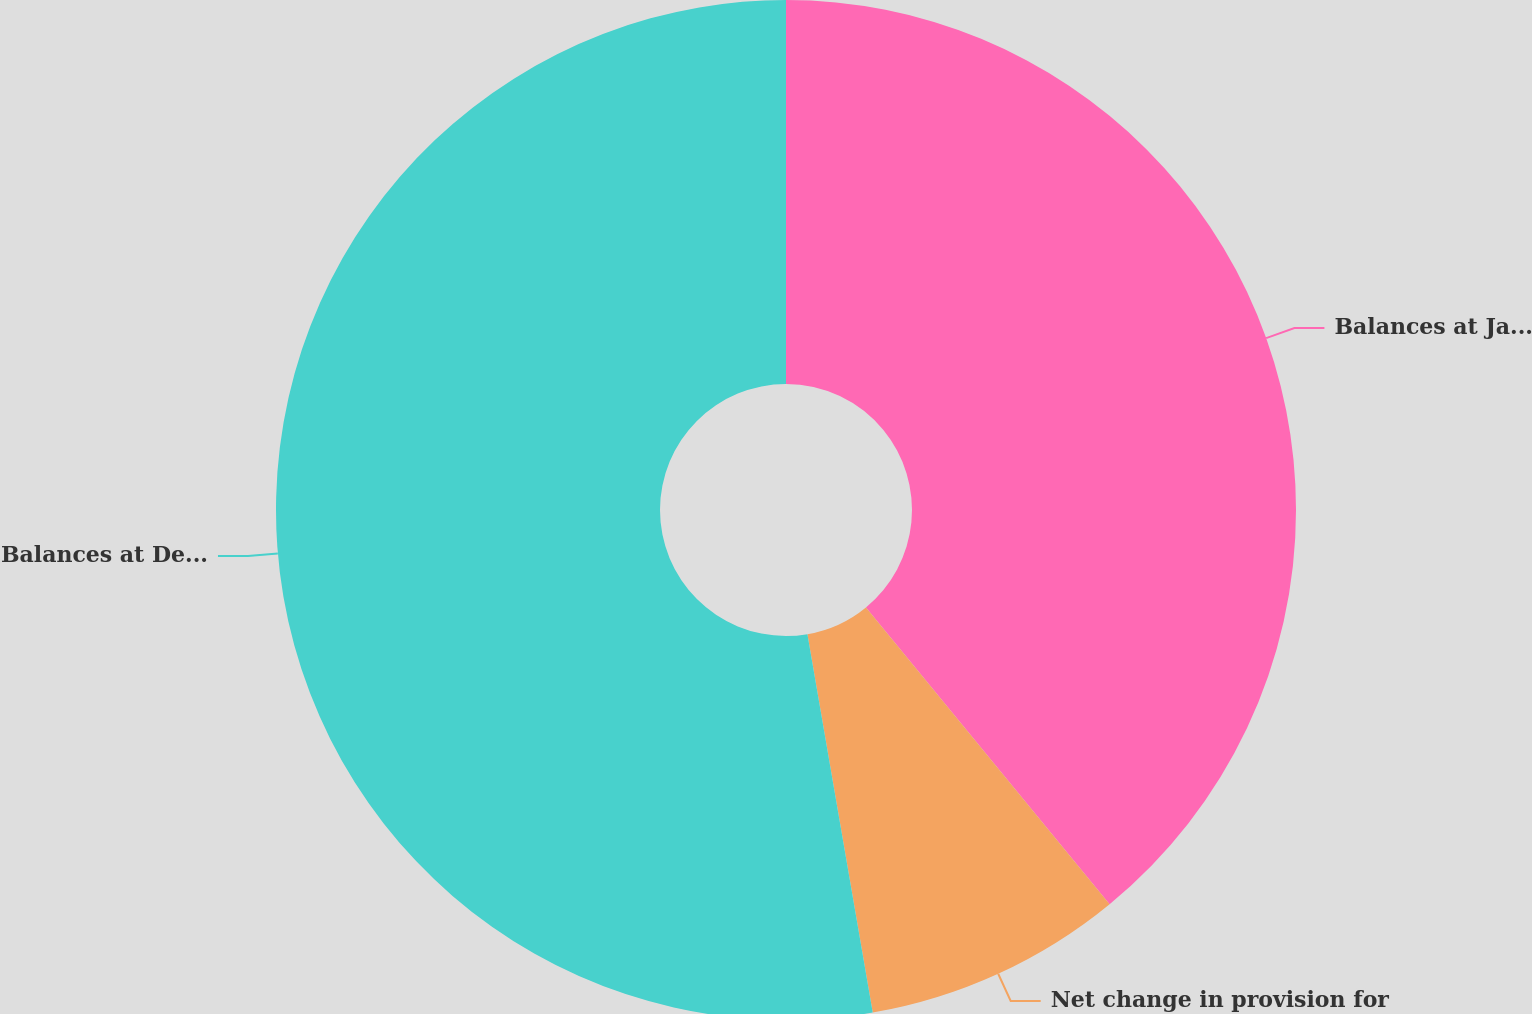Convert chart to OTSL. <chart><loc_0><loc_0><loc_500><loc_500><pie_chart><fcel>Balances at January 1 2007<fcel>Net change in provision for<fcel>Balances at December 31 2007<nl><fcel>39.06%<fcel>8.22%<fcel>52.72%<nl></chart> 